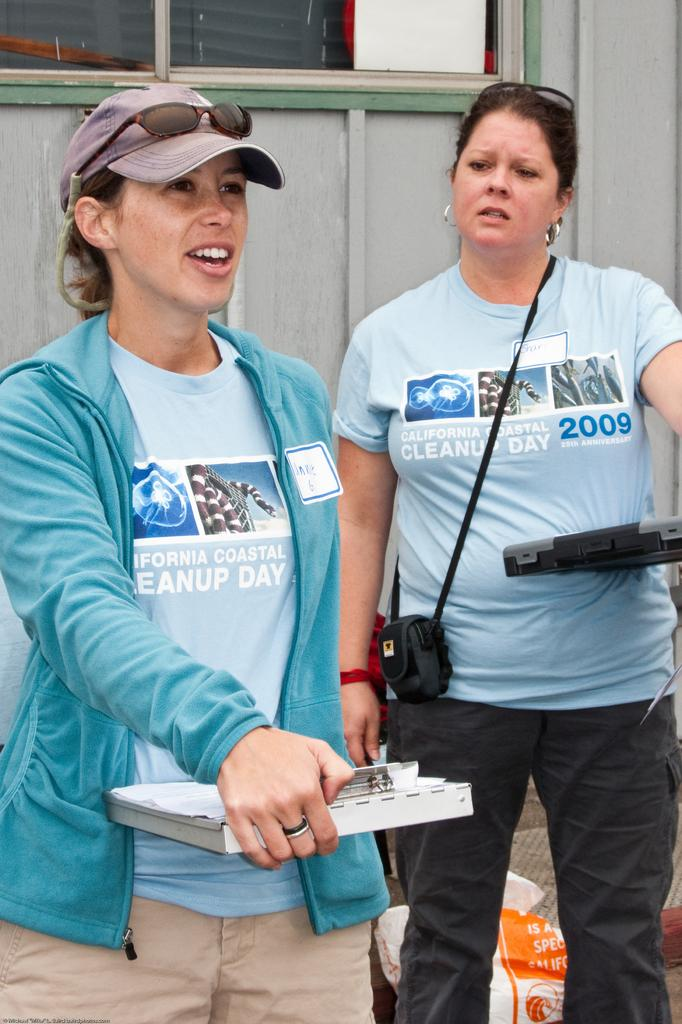Provide a one-sentence caption for the provided image. Two women wearing blue California Coastal Cleanup Day t-shirts. 